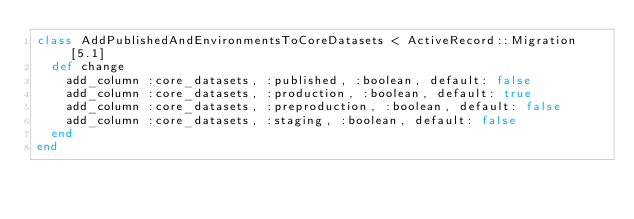Convert code to text. <code><loc_0><loc_0><loc_500><loc_500><_Ruby_>class AddPublishedAndEnvironmentsToCoreDatasets < ActiveRecord::Migration[5.1]
  def change
    add_column :core_datasets, :published, :boolean, default: false
    add_column :core_datasets, :production, :boolean, default: true
    add_column :core_datasets, :preproduction, :boolean, default: false
    add_column :core_datasets, :staging, :boolean, default: false
  end
end
</code> 